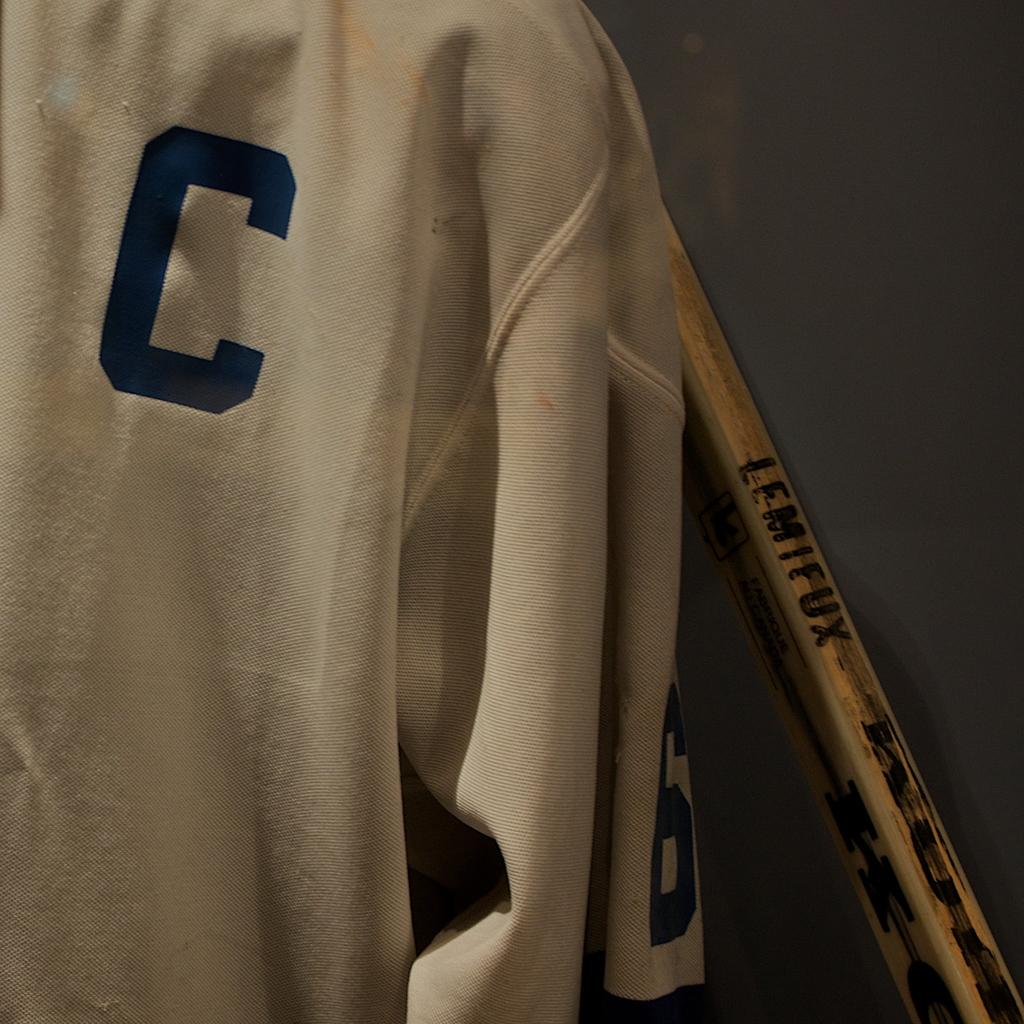What letter is found on the jersey?
Give a very brief answer. C. 